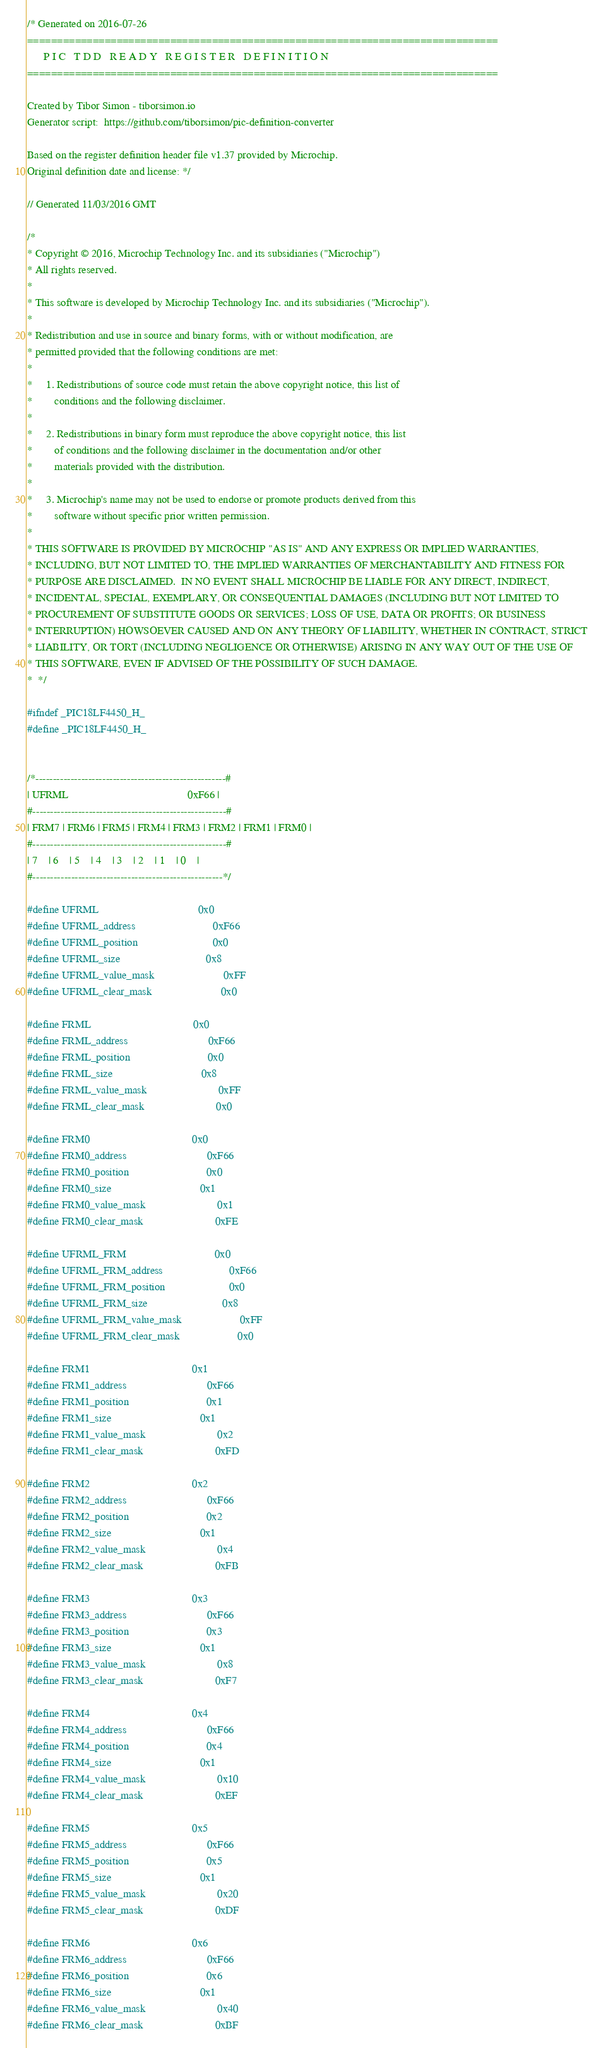Convert code to text. <code><loc_0><loc_0><loc_500><loc_500><_C_>/* Generated on 2016-07-26
===============================================================================
      P I C   T D D   R E A D Y   R E G I S T E R   D E F I N I T I O N
===============================================================================

Created by Tibor Simon - tiborsimon.io
Generator script:  https://github.com/tiborsimon/pic-definition-converter

Based on the register definition header file v1.37 provided by Microchip.
Original definition date and license: */

// Generated 11/03/2016 GMT

/*
* Copyright © 2016, Microchip Technology Inc. and its subsidiaries ("Microchip")
* All rights reserved.
*
* This software is developed by Microchip Technology Inc. and its subsidiaries ("Microchip").
*
* Redistribution and use in source and binary forms, with or without modification, are
* permitted provided that the following conditions are met:
*
*     1. Redistributions of source code must retain the above copyright notice, this list of
*        conditions and the following disclaimer.
*
*     2. Redistributions in binary form must reproduce the above copyright notice, this list
*        of conditions and the following disclaimer in the documentation and/or other
*        materials provided with the distribution.
*
*     3. Microchip's name may not be used to endorse or promote products derived from this
*        software without specific prior written permission.
*
* THIS SOFTWARE IS PROVIDED BY MICROCHIP "AS IS" AND ANY EXPRESS OR IMPLIED WARRANTIES,
* INCLUDING, BUT NOT LIMITED TO, THE IMPLIED WARRANTIES OF MERCHANTABILITY AND FITNESS FOR
* PURPOSE ARE DISCLAIMED.  IN NO EVENT SHALL MICROCHIP BE LIABLE FOR ANY DIRECT, INDIRECT,
* INCIDENTAL, SPECIAL, EXEMPLARY, OR CONSEQUENTIAL DAMAGES (INCLUDING BUT NOT LIMITED TO
* PROCUREMENT OF SUBSTITUTE GOODS OR SERVICES; LOSS OF USE, DATA OR PROFITS; OR BUSINESS
* INTERRUPTION) HOWSOEVER CAUSED AND ON ANY THEORY OF LIABILITY, WHETHER IN CONTRACT, STRICT
* LIABILITY, OR TORT (INCLUDING NEGLIGENCE OR OTHERWISE) ARISING IN ANY WAY OUT OF THE USE OF
* THIS SOFTWARE, EVEN IF ADVISED OF THE POSSIBILITY OF SUCH DAMAGE.
*  */

#ifndef _PIC18LF4450_H_
#define _PIC18LF4450_H_


/*------------------------------------------------------#
| UFRML                                           0xF66 |
#-------------------------------------------------------#
| FRM7 | FRM6 | FRM5 | FRM4 | FRM3 | FRM2 | FRM1 | FRM0 |
#-------------------------------------------------------#
| 7    | 6    | 5    | 4    | 3    | 2    | 1    | 0    |
#------------------------------------------------------*/

#define UFRML                                    0x0
#define UFRML_address                            0xF66
#define UFRML_position                           0x0
#define UFRML_size                               0x8
#define UFRML_value_mask                         0xFF
#define UFRML_clear_mask                         0x0

#define FRML                                     0x0
#define FRML_address                             0xF66
#define FRML_position                            0x0
#define FRML_size                                0x8
#define FRML_value_mask                          0xFF
#define FRML_clear_mask                          0x0

#define FRM0                                     0x0
#define FRM0_address                             0xF66
#define FRM0_position                            0x0
#define FRM0_size                                0x1
#define FRM0_value_mask                          0x1
#define FRM0_clear_mask                          0xFE

#define UFRML_FRM                                0x0
#define UFRML_FRM_address                        0xF66
#define UFRML_FRM_position                       0x0
#define UFRML_FRM_size                           0x8
#define UFRML_FRM_value_mask                     0xFF
#define UFRML_FRM_clear_mask                     0x0

#define FRM1                                     0x1
#define FRM1_address                             0xF66
#define FRM1_position                            0x1
#define FRM1_size                                0x1
#define FRM1_value_mask                          0x2
#define FRM1_clear_mask                          0xFD

#define FRM2                                     0x2
#define FRM2_address                             0xF66
#define FRM2_position                            0x2
#define FRM2_size                                0x1
#define FRM2_value_mask                          0x4
#define FRM2_clear_mask                          0xFB

#define FRM3                                     0x3
#define FRM3_address                             0xF66
#define FRM3_position                            0x3
#define FRM3_size                                0x1
#define FRM3_value_mask                          0x8
#define FRM3_clear_mask                          0xF7

#define FRM4                                     0x4
#define FRM4_address                             0xF66
#define FRM4_position                            0x4
#define FRM4_size                                0x1
#define FRM4_value_mask                          0x10
#define FRM4_clear_mask                          0xEF

#define FRM5                                     0x5
#define FRM5_address                             0xF66
#define FRM5_position                            0x5
#define FRM5_size                                0x1
#define FRM5_value_mask                          0x20
#define FRM5_clear_mask                          0xDF

#define FRM6                                     0x6
#define FRM6_address                             0xF66
#define FRM6_position                            0x6
#define FRM6_size                                0x1
#define FRM6_value_mask                          0x40
#define FRM6_clear_mask                          0xBF
</code> 